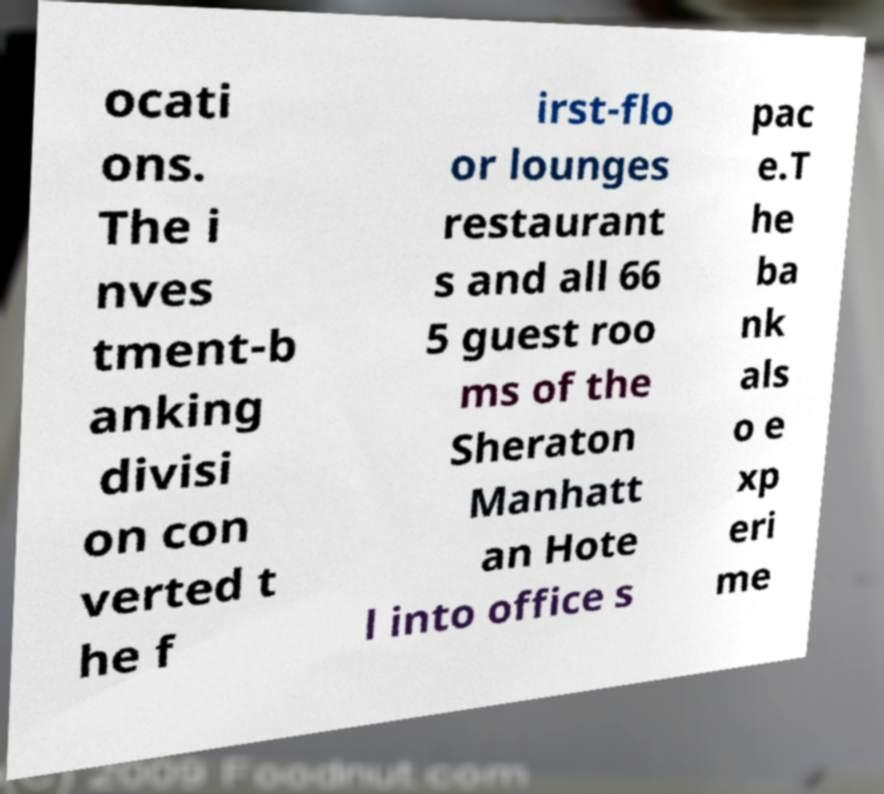Could you assist in decoding the text presented in this image and type it out clearly? ocati ons. The i nves tment-b anking divisi on con verted t he f irst-flo or lounges restaurant s and all 66 5 guest roo ms of the Sheraton Manhatt an Hote l into office s pac e.T he ba nk als o e xp eri me 